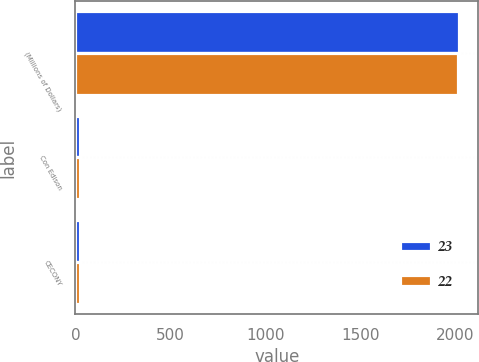<chart> <loc_0><loc_0><loc_500><loc_500><stacked_bar_chart><ecel><fcel>(Millions of Dollars)<fcel>Con Edison<fcel>CECONY<nl><fcel>23<fcel>2018<fcel>24<fcel>23<nl><fcel>22<fcel>2016<fcel>24<fcel>22<nl></chart> 